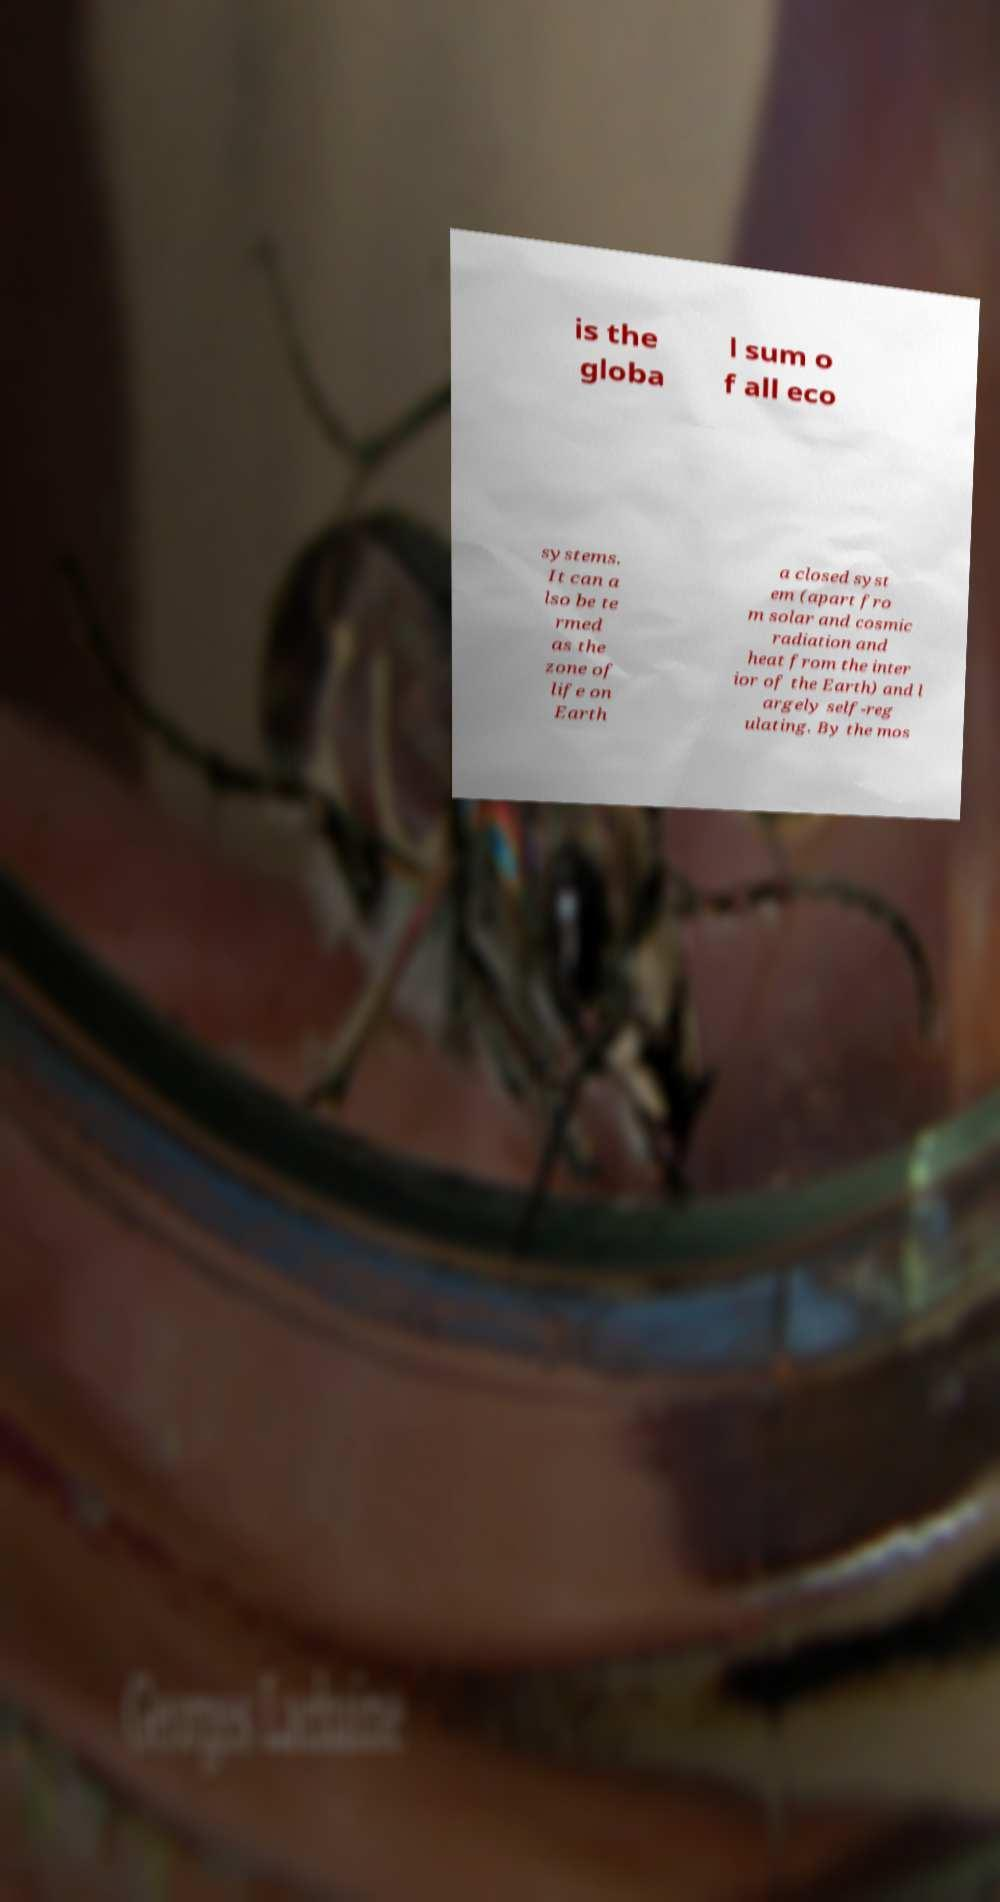There's text embedded in this image that I need extracted. Can you transcribe it verbatim? is the globa l sum o f all eco systems. It can a lso be te rmed as the zone of life on Earth a closed syst em (apart fro m solar and cosmic radiation and heat from the inter ior of the Earth) and l argely self-reg ulating. By the mos 